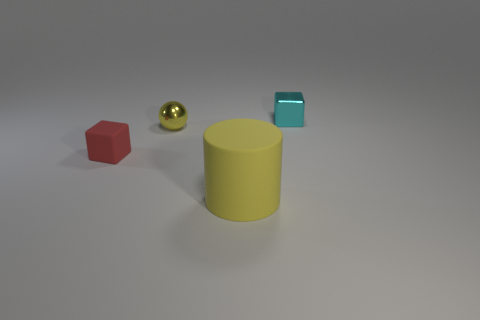Add 2 large cylinders. How many objects exist? 6 Subtract all cylinders. How many objects are left? 3 Subtract all objects. Subtract all small gray matte blocks. How many objects are left? 0 Add 2 large cylinders. How many large cylinders are left? 3 Add 4 small shiny objects. How many small shiny objects exist? 6 Subtract 1 yellow balls. How many objects are left? 3 